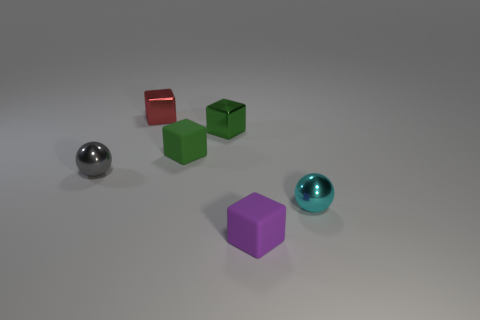There is a small ball that is to the right of the tiny rubber cube that is in front of the small ball that is to the left of the red shiny block; what is its color?
Keep it short and to the point. Cyan. There is another cube that is the same material as the red block; what color is it?
Offer a terse response. Green. Is there anything else that has the same size as the gray object?
Keep it short and to the point. Yes. What number of things are tiny blocks that are in front of the tiny gray metallic object or cubes that are behind the gray metallic object?
Your response must be concise. 4. There is a matte object that is in front of the small cyan metal sphere; is it the same size as the block that is left of the green matte cube?
Provide a short and direct response. Yes. What color is the other thing that is the same shape as the cyan shiny object?
Make the answer very short. Gray. Is there anything else that has the same shape as the cyan thing?
Make the answer very short. Yes. Is the number of small red metallic things that are on the right side of the red shiny object greater than the number of things behind the gray sphere?
Give a very brief answer. No. What is the size of the shiny sphere on the right side of the small green rubber thing behind the rubber object that is to the right of the tiny green metallic block?
Give a very brief answer. Small. Do the small red thing and the purple object in front of the green matte object have the same material?
Your answer should be very brief. No. 